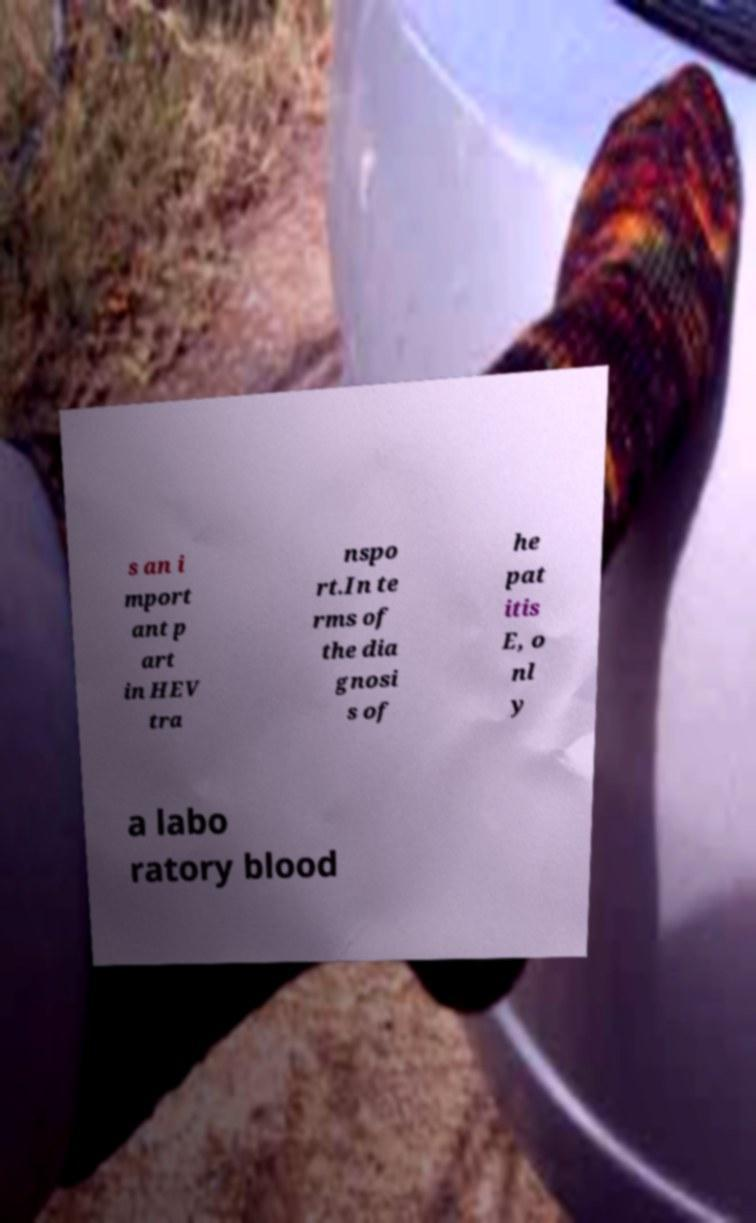There's text embedded in this image that I need extracted. Can you transcribe it verbatim? s an i mport ant p art in HEV tra nspo rt.In te rms of the dia gnosi s of he pat itis E, o nl y a labo ratory blood 